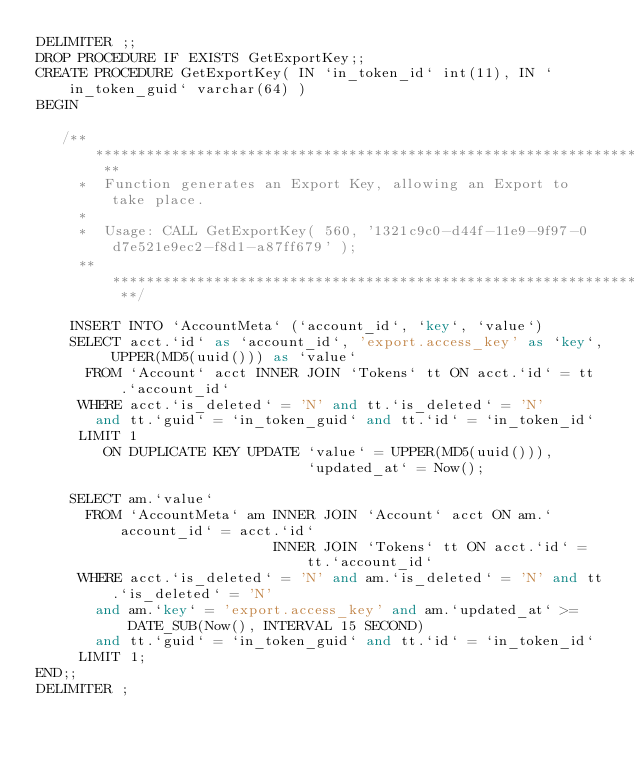Convert code to text. <code><loc_0><loc_0><loc_500><loc_500><_SQL_>DELIMITER ;;
DROP PROCEDURE IF EXISTS GetExportKey;;
CREATE PROCEDURE GetExportKey( IN `in_token_id` int(11), IN `in_token_guid` varchar(64) )
BEGIN

   /** ********************************************************************** **
     *  Function generates an Export Key, allowing an Export to take place.
     *
     *  Usage: CALL GetExportKey( 560, '1321c9c0-d44f-11e9-9f97-0d7e521e9ec2-f8d1-a87ff679' );
     ** ********************************************************************** **/

    INSERT INTO `AccountMeta` (`account_id`, `key`, `value`)
    SELECT acct.`id` as `account_id`, 'export.access_key' as `key`, UPPER(MD5(uuid())) as `value`
      FROM `Account` acct INNER JOIN `Tokens` tt ON acct.`id` = tt.`account_id`
     WHERE acct.`is_deleted` = 'N' and tt.`is_deleted` = 'N'
       and tt.`guid` = `in_token_guid` and tt.`id` = `in_token_id`
     LIMIT 1
        ON DUPLICATE KEY UPDATE `value` = UPPER(MD5(uuid())),
                                `updated_at` = Now();

    SELECT am.`value`
      FROM `AccountMeta` am INNER JOIN `Account` acct ON am.`account_id` = acct.`id`
                            INNER JOIN `Tokens` tt ON acct.`id` = tt.`account_id`
     WHERE acct.`is_deleted` = 'N' and am.`is_deleted` = 'N' and tt.`is_deleted` = 'N'
       and am.`key` = 'export.access_key' and am.`updated_at` >= DATE_SUB(Now(), INTERVAL 15 SECOND)
       and tt.`guid` = `in_token_guid` and tt.`id` = `in_token_id`
     LIMIT 1;
END;;
DELIMITER ;</code> 